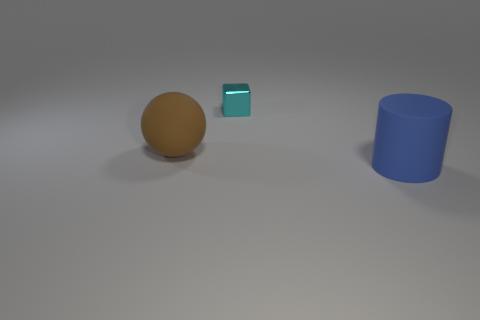Add 2 brown rubber balls. How many objects exist? 5 Subtract 1 cylinders. How many cylinders are left? 0 Subtract 0 blue blocks. How many objects are left? 3 Subtract all balls. How many objects are left? 2 Subtract all gray cylinders. Subtract all yellow spheres. How many cylinders are left? 1 Subtract all cyan cubes. How many blue balls are left? 0 Subtract all small cyan shiny cubes. Subtract all small blocks. How many objects are left? 1 Add 2 big brown matte things. How many big brown matte things are left? 3 Add 2 small matte blocks. How many small matte blocks exist? 2 